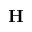Convert formula to latex. <formula><loc_0><loc_0><loc_500><loc_500>H</formula> 